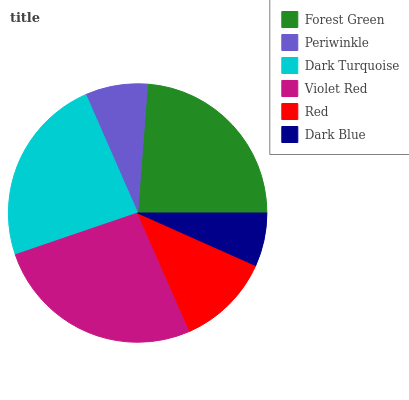Is Dark Blue the minimum?
Answer yes or no. Yes. Is Violet Red the maximum?
Answer yes or no. Yes. Is Periwinkle the minimum?
Answer yes or no. No. Is Periwinkle the maximum?
Answer yes or no. No. Is Forest Green greater than Periwinkle?
Answer yes or no. Yes. Is Periwinkle less than Forest Green?
Answer yes or no. Yes. Is Periwinkle greater than Forest Green?
Answer yes or no. No. Is Forest Green less than Periwinkle?
Answer yes or no. No. Is Dark Turquoise the high median?
Answer yes or no. Yes. Is Red the low median?
Answer yes or no. Yes. Is Red the high median?
Answer yes or no. No. Is Violet Red the low median?
Answer yes or no. No. 